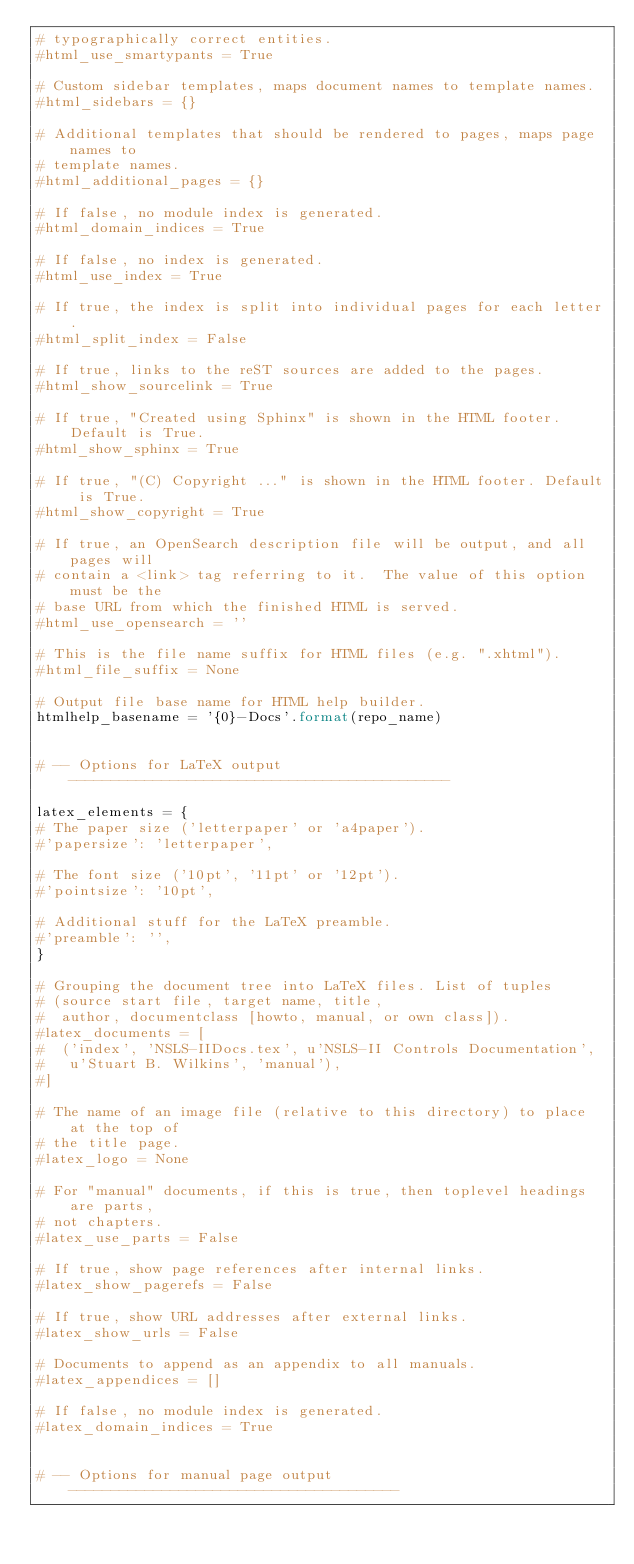<code> <loc_0><loc_0><loc_500><loc_500><_Python_># typographically correct entities.
#html_use_smartypants = True

# Custom sidebar templates, maps document names to template names.
#html_sidebars = {}

# Additional templates that should be rendered to pages, maps page names to
# template names.
#html_additional_pages = {}

# If false, no module index is generated.
#html_domain_indices = True

# If false, no index is generated.
#html_use_index = True

# If true, the index is split into individual pages for each letter.
#html_split_index = False

# If true, links to the reST sources are added to the pages.
#html_show_sourcelink = True

# If true, "Created using Sphinx" is shown in the HTML footer. Default is True.
#html_show_sphinx = True

# If true, "(C) Copyright ..." is shown in the HTML footer. Default is True.
#html_show_copyright = True

# If true, an OpenSearch description file will be output, and all pages will
# contain a <link> tag referring to it.  The value of this option must be the
# base URL from which the finished HTML is served.
#html_use_opensearch = ''

# This is the file name suffix for HTML files (e.g. ".xhtml").
#html_file_suffix = None

# Output file base name for HTML help builder.
htmlhelp_basename = '{0}-Docs'.format(repo_name)


# -- Options for LaTeX output ---------------------------------------------

latex_elements = {
# The paper size ('letterpaper' or 'a4paper').
#'papersize': 'letterpaper',

# The font size ('10pt', '11pt' or '12pt').
#'pointsize': '10pt',

# Additional stuff for the LaTeX preamble.
#'preamble': '',
}

# Grouping the document tree into LaTeX files. List of tuples
# (source start file, target name, title,
#  author, documentclass [howto, manual, or own class]).
#latex_documents = [
#  ('index', 'NSLS-IIDocs.tex', u'NSLS-II Controls Documentation',
#   u'Stuart B. Wilkins', 'manual'),
#]

# The name of an image file (relative to this directory) to place at the top of
# the title page.
#latex_logo = None

# For "manual" documents, if this is true, then toplevel headings are parts,
# not chapters.
#latex_use_parts = False

# If true, show page references after internal links.
#latex_show_pagerefs = False

# If true, show URL addresses after external links.
#latex_show_urls = False

# Documents to append as an appendix to all manuals.
#latex_appendices = []

# If false, no module index is generated.
#latex_domain_indices = True


# -- Options for manual page output ---------------------------------------
</code> 